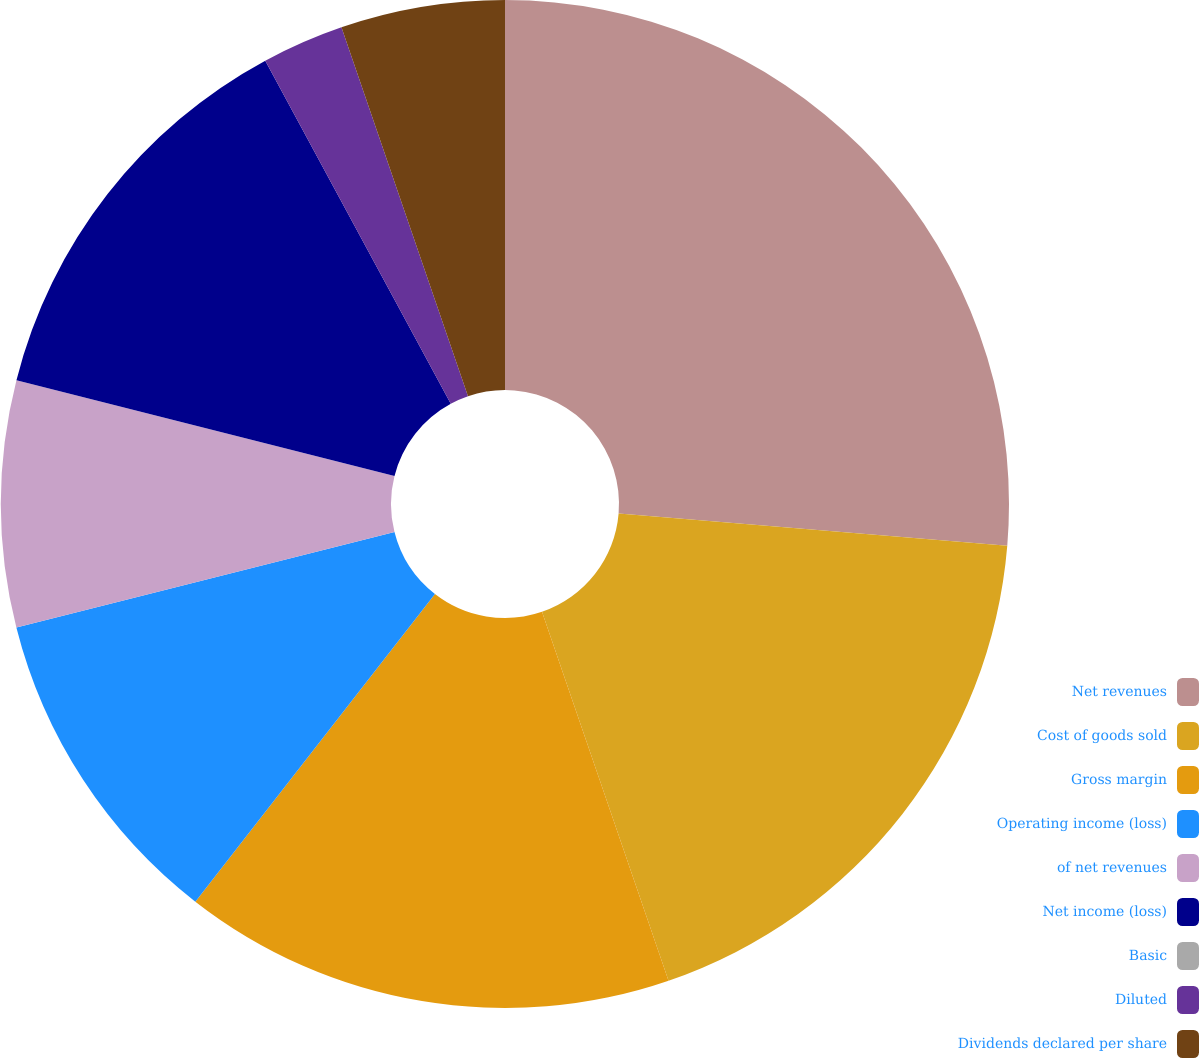Convert chart. <chart><loc_0><loc_0><loc_500><loc_500><pie_chart><fcel>Net revenues<fcel>Cost of goods sold<fcel>Gross margin<fcel>Operating income (loss)<fcel>of net revenues<fcel>Net income (loss)<fcel>Basic<fcel>Diluted<fcel>Dividends declared per share<nl><fcel>26.32%<fcel>18.42%<fcel>15.79%<fcel>10.53%<fcel>7.89%<fcel>13.16%<fcel>0.0%<fcel>2.63%<fcel>5.26%<nl></chart> 